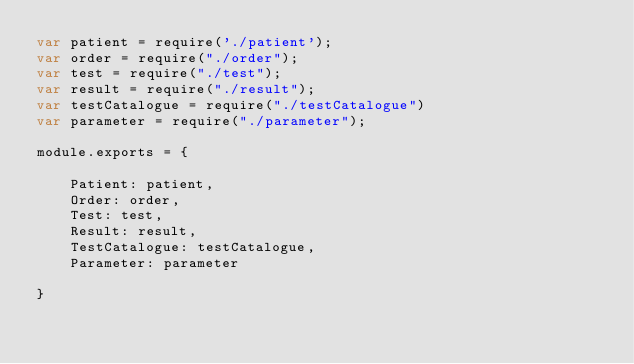<code> <loc_0><loc_0><loc_500><loc_500><_JavaScript_>var patient = require('./patient');    
var order = require("./order");
var test = require("./test");
var result = require("./result");
var testCatalogue = require("./testCatalogue")
var parameter = require("./parameter");

module.exports = {

	Patient: patient,
	Order: order,
	Test: test,
	Result: result,
	TestCatalogue: testCatalogue,
	Parameter: parameter

}</code> 